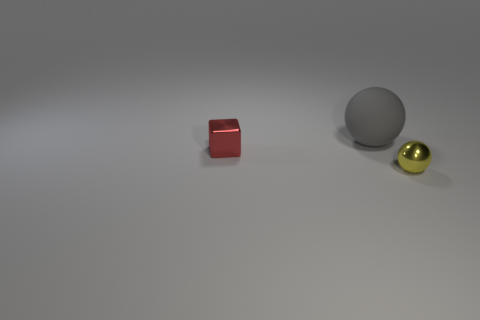Add 2 brown metal spheres. How many objects exist? 5 Subtract all blocks. How many objects are left? 2 Subtract all big gray metallic things. Subtract all big gray rubber things. How many objects are left? 2 Add 2 small blocks. How many small blocks are left? 3 Add 2 big blue matte balls. How many big blue matte balls exist? 2 Subtract 0 purple blocks. How many objects are left? 3 